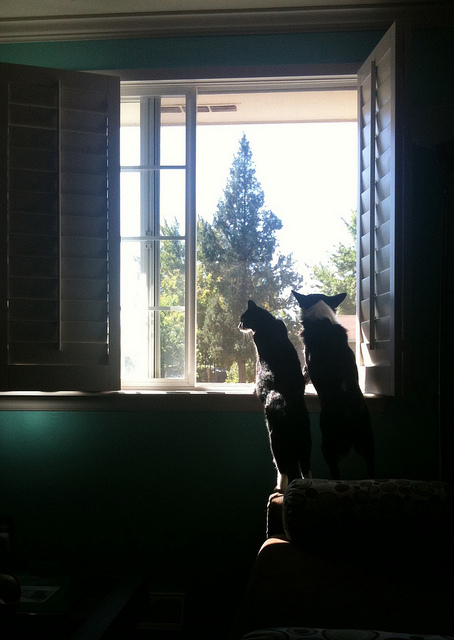<image>Who owns the cats? It is unknown who owns the cats. It could be a woman, a homeowner, or any person in the house. Who owns the cats? It is unanswerable who owns the cats. 